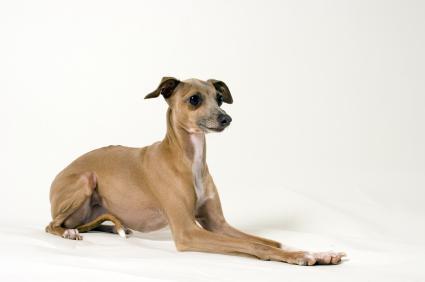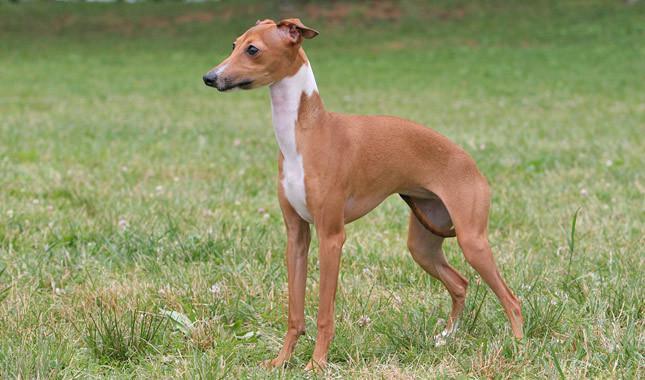The first image is the image on the left, the second image is the image on the right. Assess this claim about the two images: "Dog has a grey (blue) and white color.". Correct or not? Answer yes or no. No. 